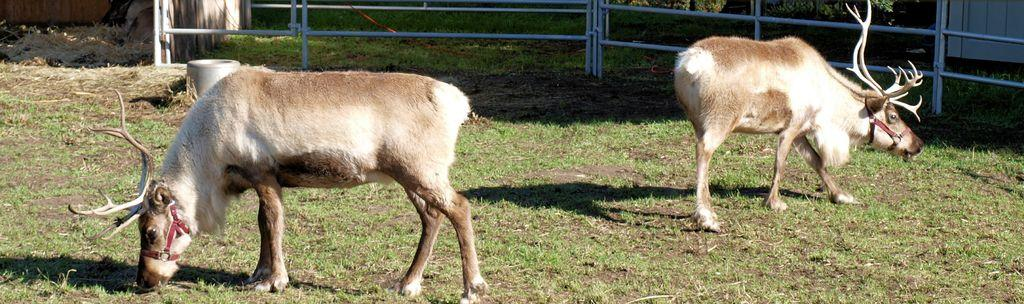What animals can be seen in the image? There are two wild deers in the image. What can be seen in the background of the image? There are iron rods, grass, and plants in the background of the image. How many sticks can be seen in the image? There are no sticks present in the image. What type of cannon is visible in the image? There is no cannon present in the image. 